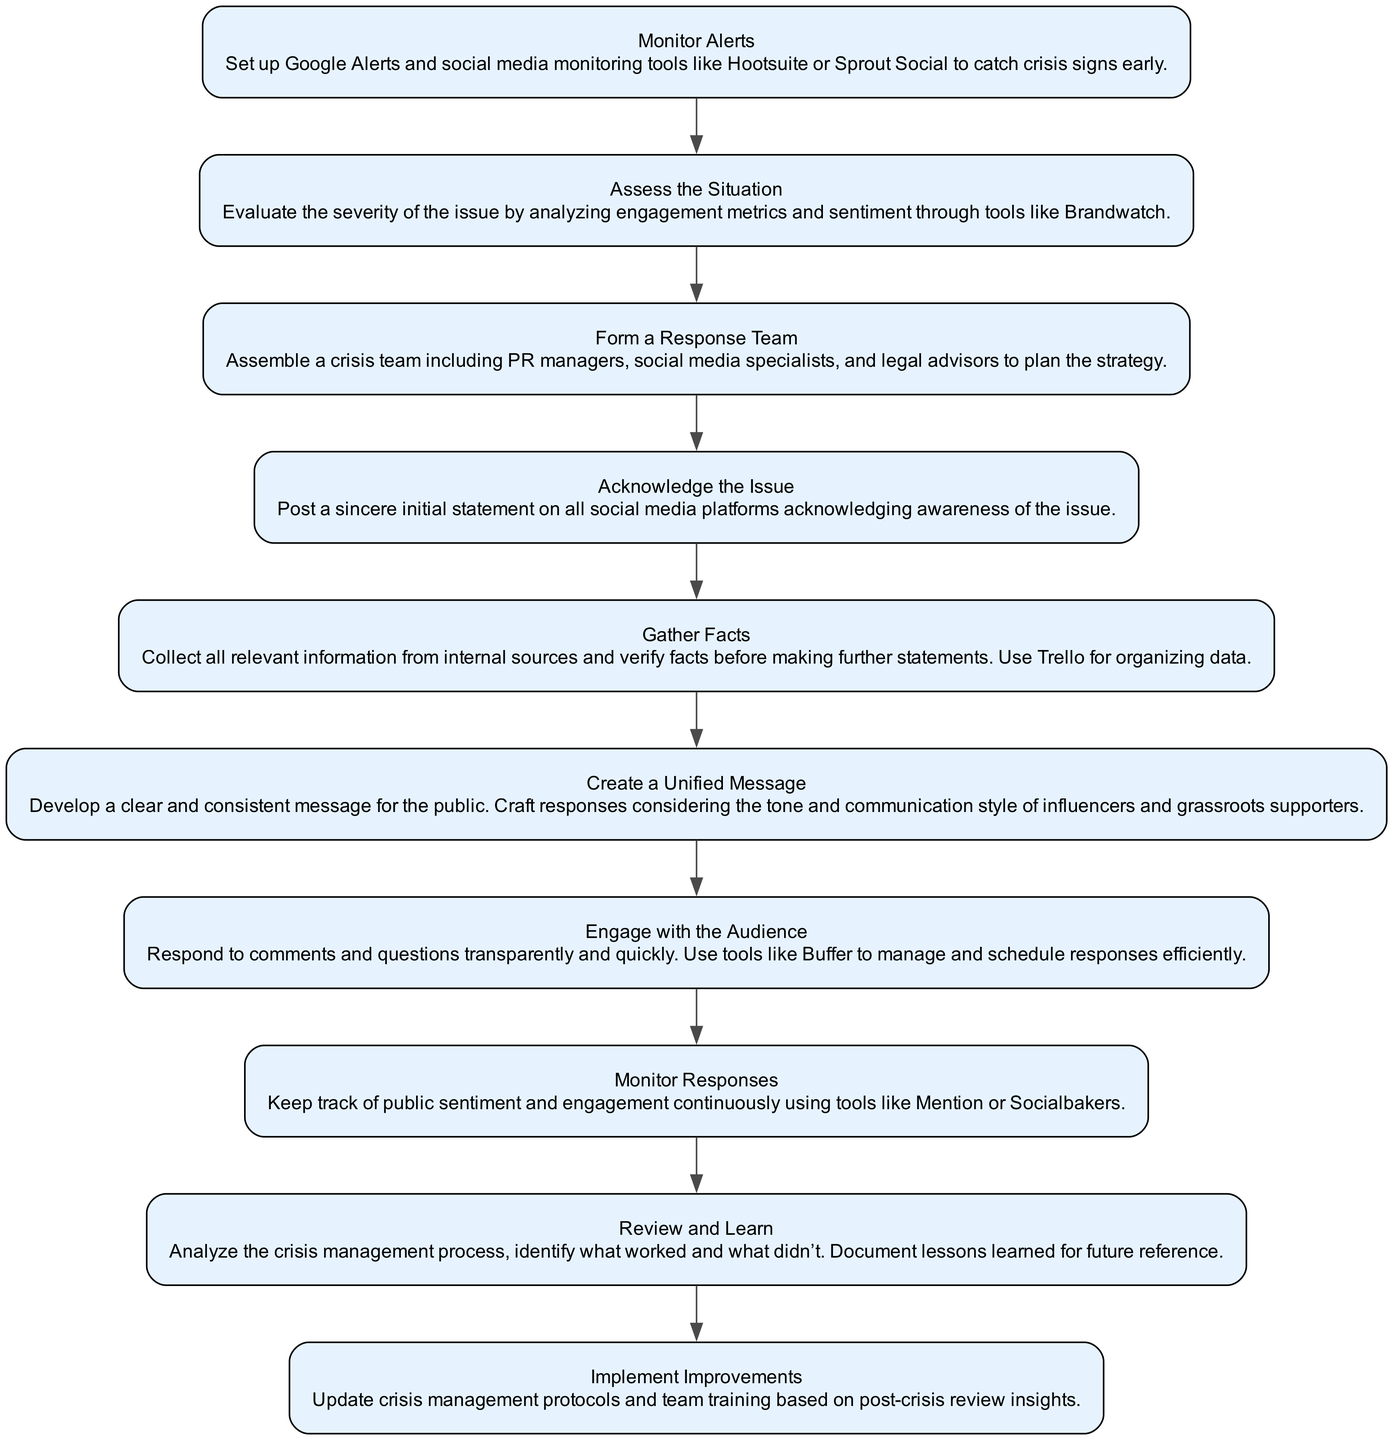What is the first step in the crisis management process? The first step in the crisis management process according to the diagram is "Monitor Alerts." This is the initial node in the flow chart that sets the stage for identifying any potential crisis early.
Answer: Monitor Alerts How many nodes are in the diagram? The total number of nodes can be counted in the diagram, which includes all major steps in the crisis management process. There are 10 specific elements listed, each represented as a node.
Answer: 10 What action should be taken after "Acknowledge the Issue"? According to the flow of the diagram, the action taken after "Acknowledge the Issue" is to "Gather Facts." This follows directly from the acknowledgment of the problem, allowing the team to collect necessary information.
Answer: Gather Facts What is the purpose of the "Engage with the Audience" step? The purpose of the "Engage with the Audience" step is to respond to comments and questions transparently and quickly. It emphasizes the importance of interacting with the audience during a crisis to maintain trust and clarity.
Answer: Respond to comments transparently What follows "Create a Unified Message" in the process? The diagram indicates that after "Create a Unified Message," the next step is to "Engage with the Audience." This indicates that communication should not only be crafted but also actively shared with the community.
Answer: Engage with the Audience Which step involves the assembly of specialists? The step that involves assembling specialists is "Form a Response Team." This is where a dedicated team of PR managers, social media specialists, and legal advisors is created to handle the crisis effectively.
Answer: Form a Response Team What should be done continuously throughout the crisis management process? The diagram highlights that "Monitor Responses" should be done continuously. It suggests that keeping track of public sentiment and engagement is vital during the entire crisis.
Answer: Monitor Responses What is the final step in the crisis management process? The last step in the process listed in the diagram is "Implement Improvements." This emphasizes the need to refine protocols and training based on the lessons learned from the crisis experience.
Answer: Implement Improvements 